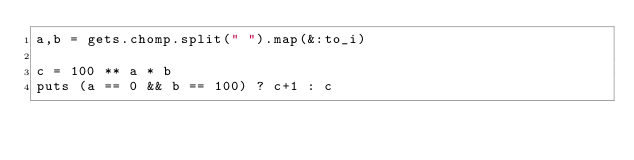Convert code to text. <code><loc_0><loc_0><loc_500><loc_500><_Ruby_>a,b = gets.chomp.split(" ").map(&:to_i)

c = 100 ** a * b
puts (a == 0 && b == 100) ? c+1 : c
</code> 